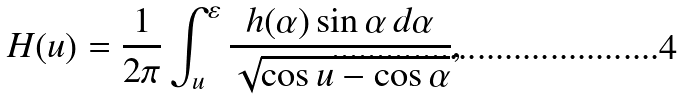Convert formula to latex. <formula><loc_0><loc_0><loc_500><loc_500>H ( u ) = \frac { 1 } { 2 \pi } \int _ { u } ^ { \varepsilon } \frac { h ( \alpha ) \sin \alpha \, d \alpha } { \sqrt { \cos u - \cos \alpha } } ,</formula> 